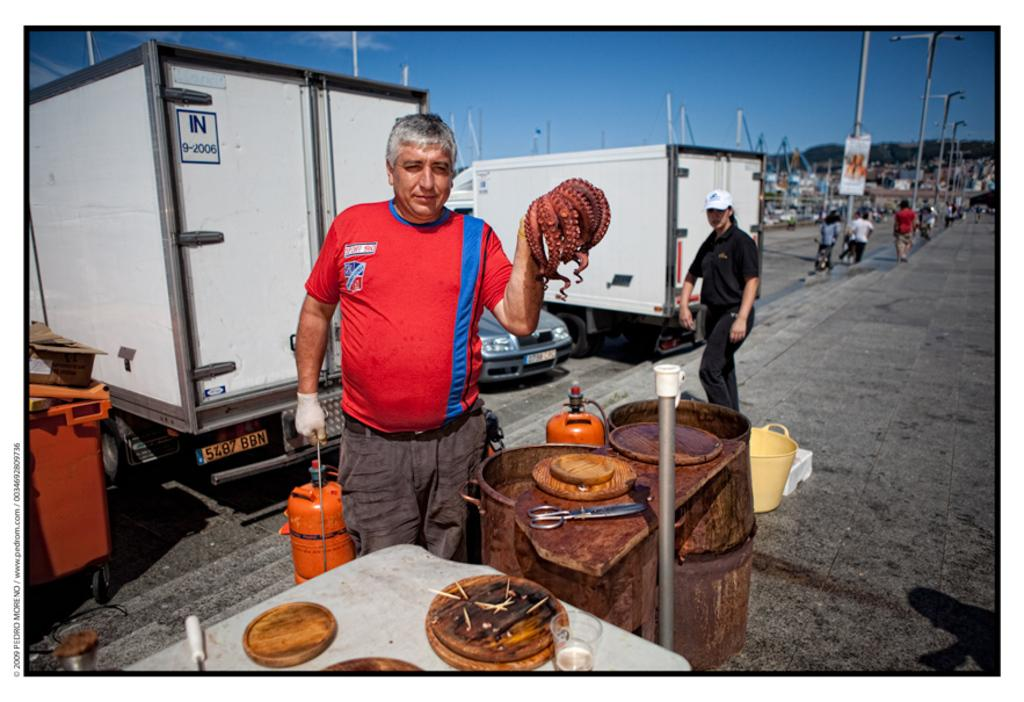What is the main subject of the image? There is a group of people on the ground. What else can be seen in the image besides the people? There are containers and some objects visible in the image. What is in the background of the image? There are poles and the sky visible in the background of the image. What type of coal is being used to attack the people in the image? There is no coal or attack present in the image; it features a group of people on the ground with containers and objects nearby. 